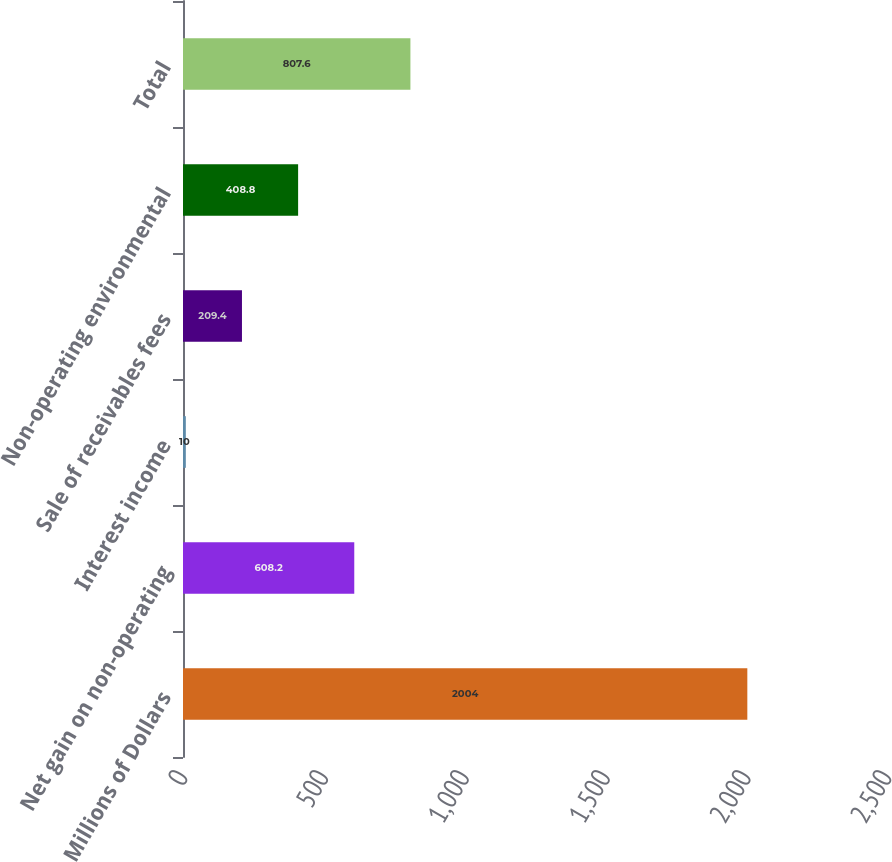<chart> <loc_0><loc_0><loc_500><loc_500><bar_chart><fcel>Millions of Dollars<fcel>Net gain on non-operating<fcel>Interest income<fcel>Sale of receivables fees<fcel>Non-operating environmental<fcel>Total<nl><fcel>2004<fcel>608.2<fcel>10<fcel>209.4<fcel>408.8<fcel>807.6<nl></chart> 